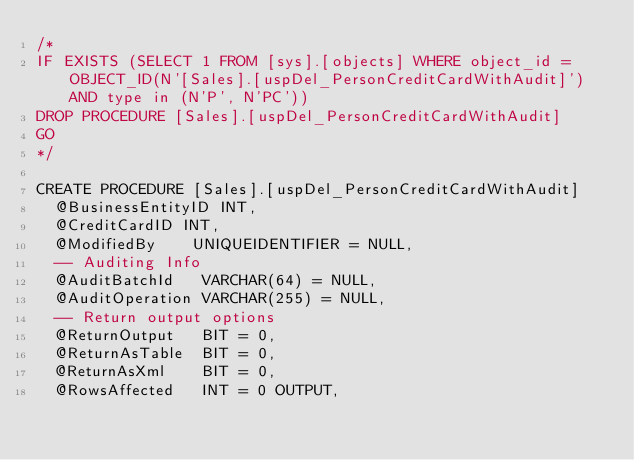<code> <loc_0><loc_0><loc_500><loc_500><_SQL_>/*
IF EXISTS (SELECT 1 FROM [sys].[objects] WHERE object_id = OBJECT_ID(N'[Sales].[uspDel_PersonCreditCardWithAudit]') AND type in (N'P', N'PC'))
DROP PROCEDURE [Sales].[uspDel_PersonCreditCardWithAudit]
GO
*/

CREATE PROCEDURE [Sales].[uspDel_PersonCreditCardWithAudit]
  @BusinessEntityID INT,
  @CreditCardID INT,
  @ModifiedBy    UNIQUEIDENTIFIER = NULL,
  -- Auditing Info
  @AuditBatchId   VARCHAR(64) = NULL,
  @AuditOperation VARCHAR(255) = NULL,
  -- Return output options
  @ReturnOutput   BIT = 0,
  @ReturnAsTable  BIT = 0,
  @ReturnAsXml    BIT = 0,
  @RowsAffected   INT = 0 OUTPUT,</code> 